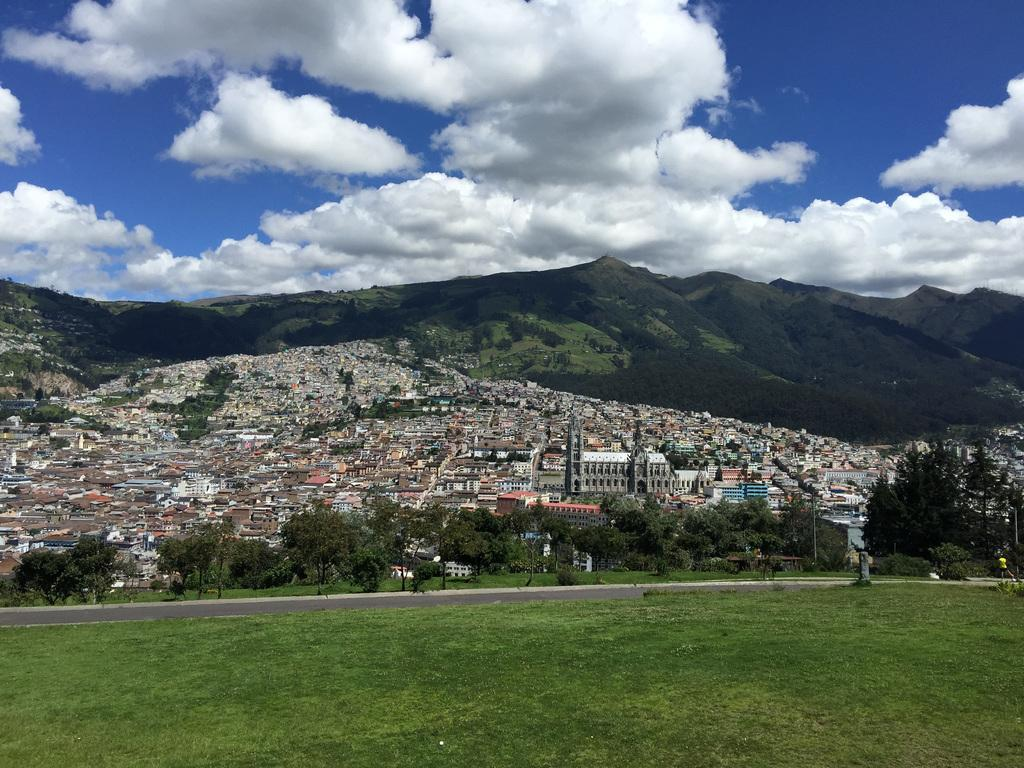What type of terrain is visible in the image? There is a ground with grass in the image. What else can be seen on the ground? There is a road in the image. What natural elements are present in the image? There are trees in the image. What man-made structures can be seen in the distance? There are buildings on a mountain in the image. What type of vessel is being used by the stick owner in the image? There is no vessel or stick owner present in the image. 